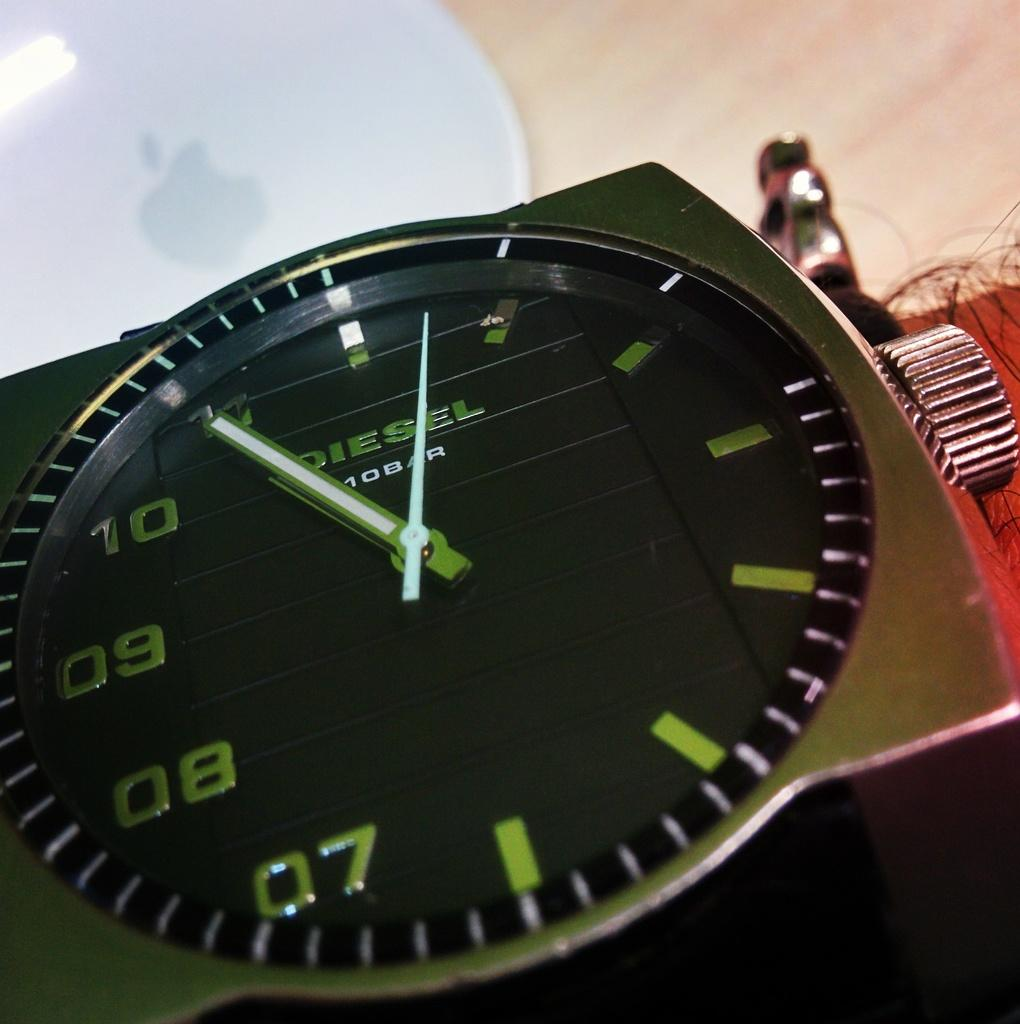<image>
Present a compact description of the photo's key features. A diesel watch shows the tme is 10:55. 